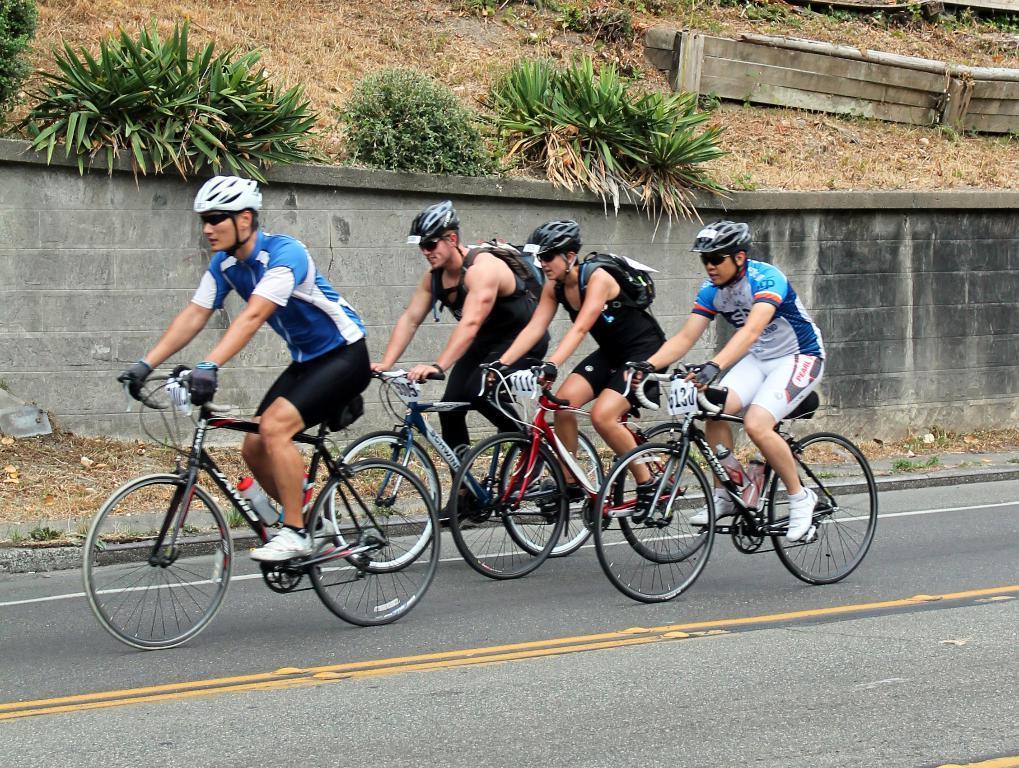Could you give a brief overview of what you see in this image? This picture shows four men riding bicycles on the road and we see few plants on the side. 